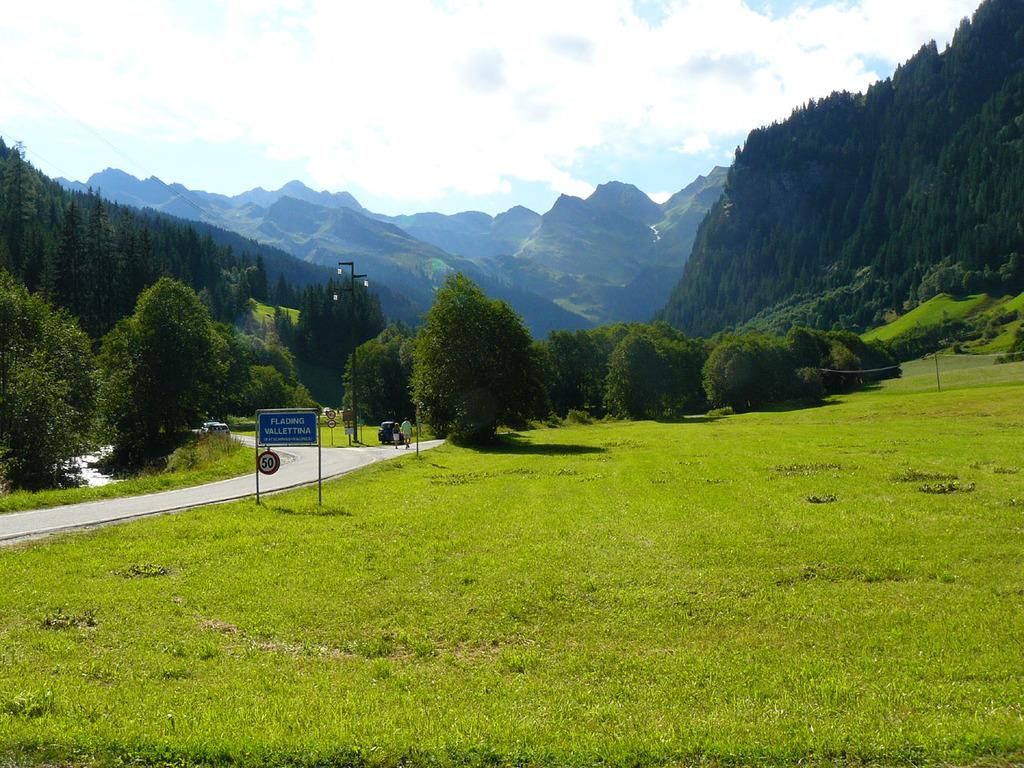What type of vegetation can be seen in the image? There is grass in the image. What type of signage is present in the image? There is a name board and sign boards in the image. How many people are visible in the image? There are two people in the image. What is the nature of the transportation visible in the image? There are vehicles on the road in the image. What structure can be seen in the image? There is a pole in the image. What type of natural features are present in the image? There are trees and mountains in the image. What can be seen in the background of the image? The sky is visible in the background of the image, with clouds present. Can you see any snails crawling on the grass in the image? There is no mention of snails in the image, so we cannot determine if any are present. What sound does the bell make in the image? There is no bell present in the image. Are there any volcanoes visible in the image? There is no mention of a volcano in the image, so we cannot determine if one is present. 